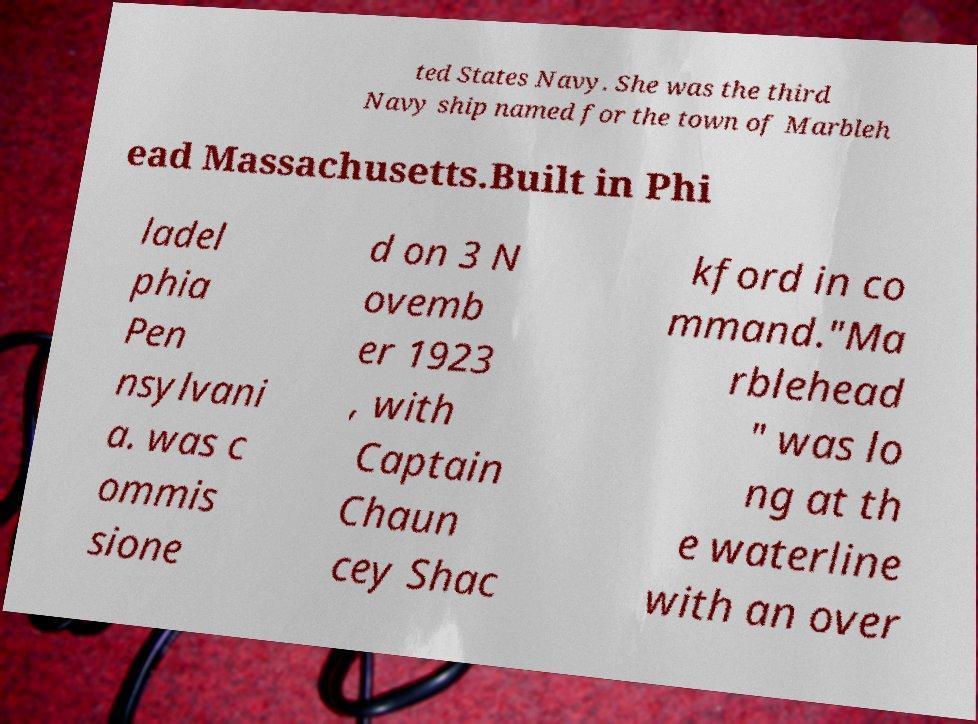Can you accurately transcribe the text from the provided image for me? ted States Navy. She was the third Navy ship named for the town of Marbleh ead Massachusetts.Built in Phi ladel phia Pen nsylvani a. was c ommis sione d on 3 N ovemb er 1923 , with Captain Chaun cey Shac kford in co mmand."Ma rblehead " was lo ng at th e waterline with an over 